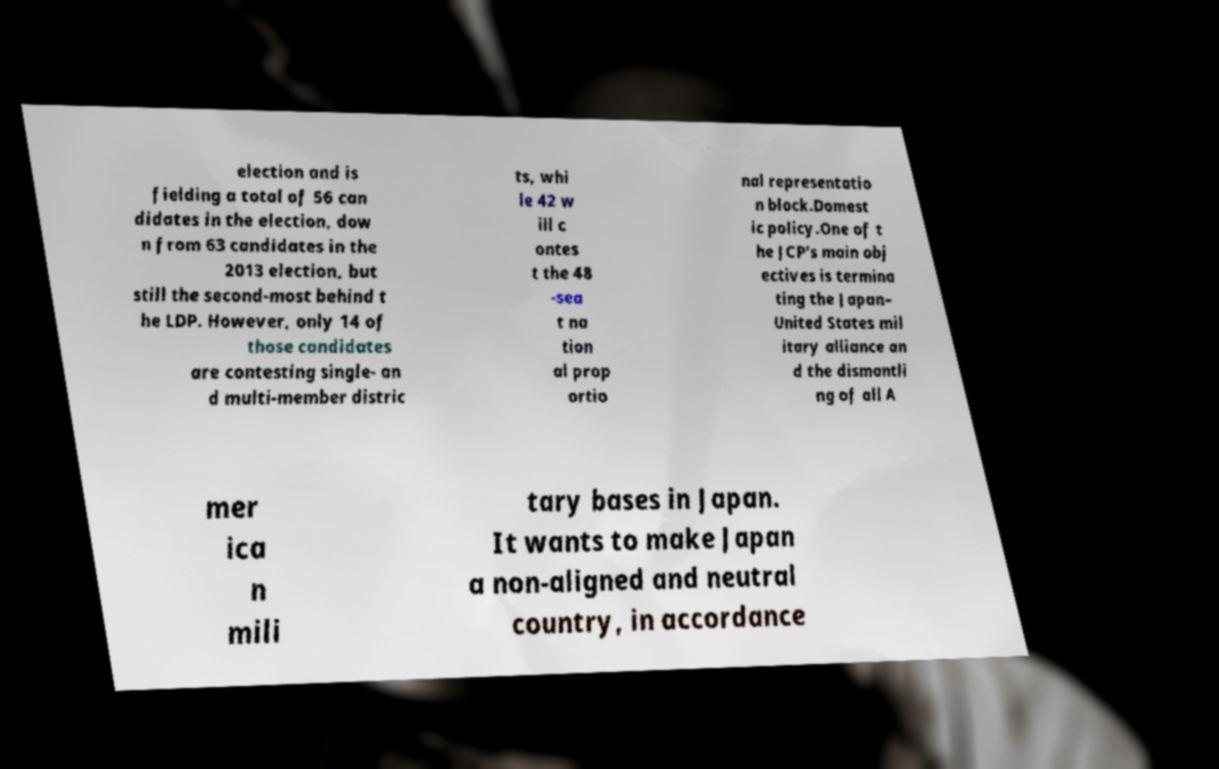What messages or text are displayed in this image? I need them in a readable, typed format. election and is fielding a total of 56 can didates in the election, dow n from 63 candidates in the 2013 election, but still the second-most behind t he LDP. However, only 14 of those candidates are contesting single- an d multi-member distric ts, whi le 42 w ill c ontes t the 48 -sea t na tion al prop ortio nal representatio n block.Domest ic policy.One of t he JCP's main obj ectives is termina ting the Japan– United States mil itary alliance an d the dismantli ng of all A mer ica n mili tary bases in Japan. It wants to make Japan a non-aligned and neutral country, in accordance 